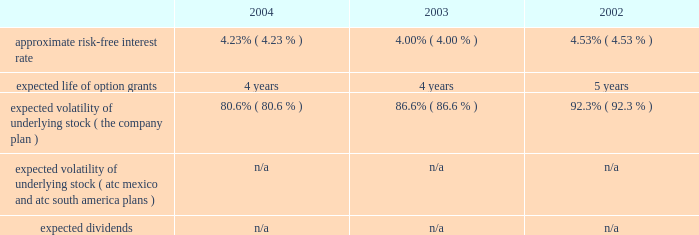American tower corporation and subsidiaries notes to consolidated financial statements 2014 ( continued ) pro forma disclosure 2014the company has adopted the disclosure-only provisions of sfas no .
123 , as amended by sfas no .
148 , and has presented such disclosure in note 1 .
The 201cfair value 201d of each option grant is estimated on the date of grant using the black-scholes option pricing model .
The weighted average fair values of the company 2019s options granted during 2004 , 2003 and 2002 were $ 7.05 , $ 6.32 , and $ 2.23 per share , respectively .
Key assumptions used to apply this pricing model are as follows: .
Voluntary option exchanges 2014in february 2004 , the company issued to eligible employees 1032717 options with an exercise price of $ 11.19 per share , the fair market value of the class a common stock on the date of grant .
These options were issued in connection with a voluntary option exchange program entered into by the company in august 2003 , where the company accepted for surrender and cancelled options ( having an exercise price of $ 10.25 or greater ) to purchase 1831981 shares of its class a common stock .
The program , which was offered to both full and part-time employees , excluding the company 2019s executive officers and its directors , called for the grant ( at least six months and one day from the surrender date to employees still employed on that date ) of new options exercisable for two shares of class a common stock for every three shares of class a common stock issuable upon exercise of a surrendered option .
No options were granted to any employees who participated in the exchange offer between the cancellation date and the new grant date .
In may 2002 , the company issued to eligible employees 2027612 options with an exercise price of $ 3.84 per share , the fair market value of the class a common stock on the date of grant .
These options were issued in connection with a voluntary option exchange program entered into by the company in october 2001 , where the company accepted for surrender and cancelled options to purchase 3471211 shares of its class a common stock .
The program , which was offered to both full and part-time employees , excluding most of the company 2019s executive officers , called for the grant ( at least six months and one day from the surrender date to employees still employed on that date ) of new options exercisable for two shares of class a common stock for every three shares of class a common stock issuable upon exercise of a surrendered option .
No options were granted to any employees who participated in the exchange offer between the cancellation date and the new grant date .
Atc mexico holding stock option plan 2014the company maintains a stock option plan in its atc mexico subsidiary ( atc mexico plan ) .
The atc mexico plan provides for the issuance of options to officers , employees , directors and consultants of atc mexico .
The atc mexico plan limits the number of shares of common stock which may be granted to an aggregate of 360 shares , subject to adjustment based on changes in atc mexico 2019s capital structure .
During 2002 , atc mexico granted options to purchase 318 shares of atc mexico common stock to officers and employees .
Such options were issued at one time with an exercise price of $ 10000 per share .
The exercise price per share was at fair market value as determined by the board of directors with the assistance of an independent appraisal performed at the company 2019s request .
The fair value of atc mexico plan options granted during 2002 were $ 3611 per share as determined by using the black-scholes option pricing model .
As described in note 10 , all outstanding options were exercised in march 2004 .
No options under the atc mexico plan were granted in 2004 or 2003 , or exercised or cancelled in 2003 or 2002 , and no options were exercisable as of december 31 , 2003 or 2002 .
( see note 10. ) .
What is the growth rate in weighted average fair values of the company 2019s options granted from 2002 to 2003? 
Computations: ((6.32 - 2.23) / 2.23)
Answer: 1.83408. 